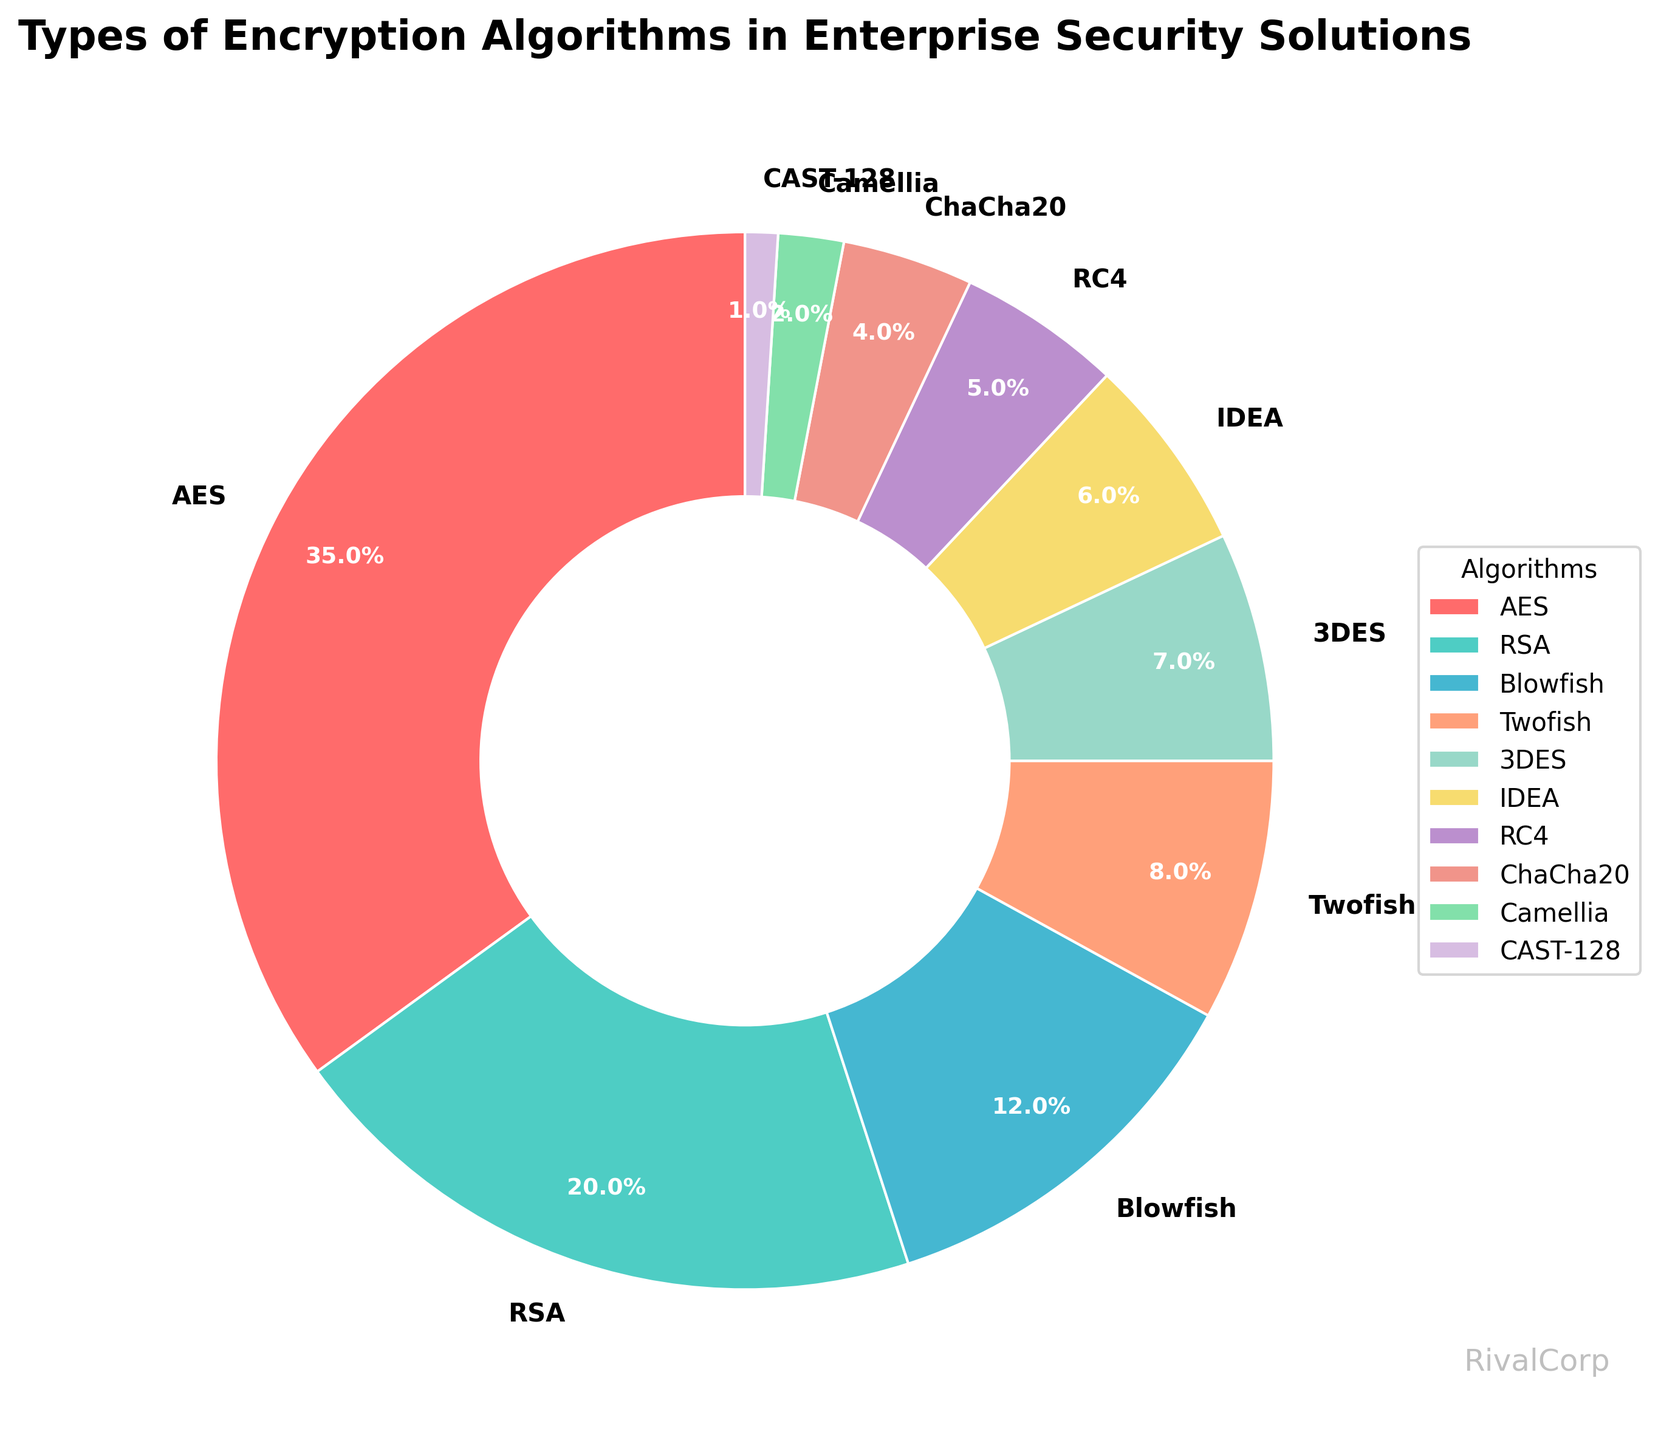Which encryption algorithm is most commonly used in enterprise security solutions? By observing the pie chart, the algorithm with the largest slice denotes the most commonly used algorithm. The AES algorithm occupies the largest portion.
Answer: AES What is the combined percentage of Blowfish and Twofish algorithms used in enterprise security solutions? To find the combined percentage, add the percentages of Blowfish and Twofish together. Blowfish is 12% and Twofish is 8%, so 12% + 8% = 20%.
Answer: 20% How much more common is AES compared to RSA in terms of percentage? To determine how much more common AES is than RSA, subtract the percentage of RSA from the percentage of AES. AES is 35% and RSA is 20%, so 35% - 20% = 15%.
Answer: 15% Which encryption algorithms together make up exactly half of the pie chart? To find which algorithms together make up 50%, examine and sum their percentages until reaching 50%. The first algorithms adding up to this value are AES (35%) and RSA (20%), so AES + RSA > 50%. Another combination must be inferred from trial and error with smaller values.
Answer: None make exactly 50% What is the percentage difference between the least and the most commonly used encryption algorithms? The least commonly used algorithm is CAST-128 at 1%, and the most commonly used is AES at 35%. The difference is 35% - 1% = 34%.
Answer: 34% If we remove the percentages of the three least common algorithms from the total, what will the remaining sum be? The three least common algorithms are CAST-128 (1%), Camellia (2%), and ChaCha20 (4%). Removing their percentages from 100% involves 100% - (1% + 2% + 4%) = 93%.
Answer: 93% What is the percentage of the algorithms other than AES and RSA? First sum the percentage of AES and RSA, which is 35% + 20% = 55%. Then subtract this from the total percentage: 100% - 55% = 45%.
Answer: 45% Which algorithm has a slice colored in a shade of green? Identifying the color associated with "green" in the provided data, RC4, has a wedge likely to be green based on the description.
Answer: RC4 